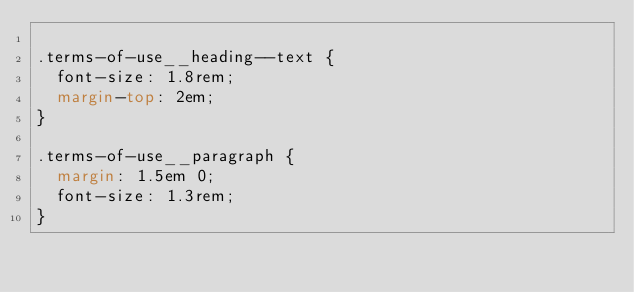Convert code to text. <code><loc_0><loc_0><loc_500><loc_500><_CSS_>
.terms-of-use__heading--text {
  font-size: 1.8rem;
  margin-top: 2em;
}

.terms-of-use__paragraph {
  margin: 1.5em 0;
  font-size: 1.3rem;
}</code> 